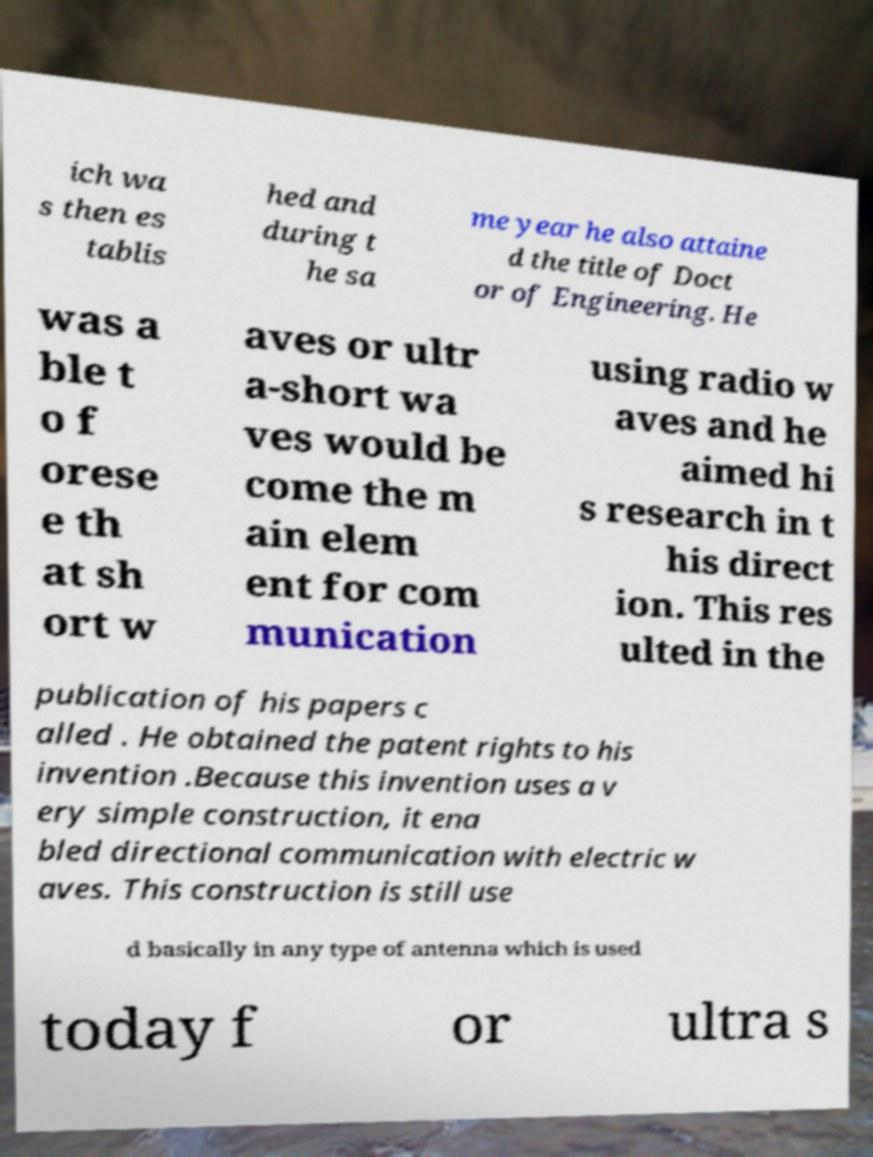Can you read and provide the text displayed in the image?This photo seems to have some interesting text. Can you extract and type it out for me? ich wa s then es tablis hed and during t he sa me year he also attaine d the title of Doct or of Engineering. He was a ble t o f orese e th at sh ort w aves or ultr a-short wa ves would be come the m ain elem ent for com munication using radio w aves and he aimed hi s research in t his direct ion. This res ulted in the publication of his papers c alled . He obtained the patent rights to his invention .Because this invention uses a v ery simple construction, it ena bled directional communication with electric w aves. This construction is still use d basically in any type of antenna which is used today f or ultra s 